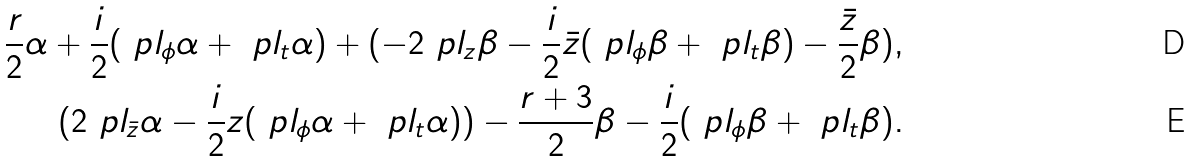<formula> <loc_0><loc_0><loc_500><loc_500>\frac { r } { 2 } \alpha + \frac { i } { 2 } ( \ p l _ { \phi } \alpha + \ p l _ { t } \alpha ) + ( - 2 \ p l _ { z } \beta - \frac { i } { 2 } \bar { z } ( \ p l _ { \phi } \beta + \ p l _ { t } \beta ) - \frac { \bar { z } } { 2 } \beta ) , \\ ( 2 \ p l _ { \bar { z } } \alpha - \frac { i } { 2 } z ( \ p l _ { \phi } \alpha + \ p l _ { t } \alpha ) ) - \frac { r + 3 } { 2 } \beta - \frac { i } { 2 } ( \ p l _ { \phi } \beta + \ p l _ { t } \beta ) .</formula> 